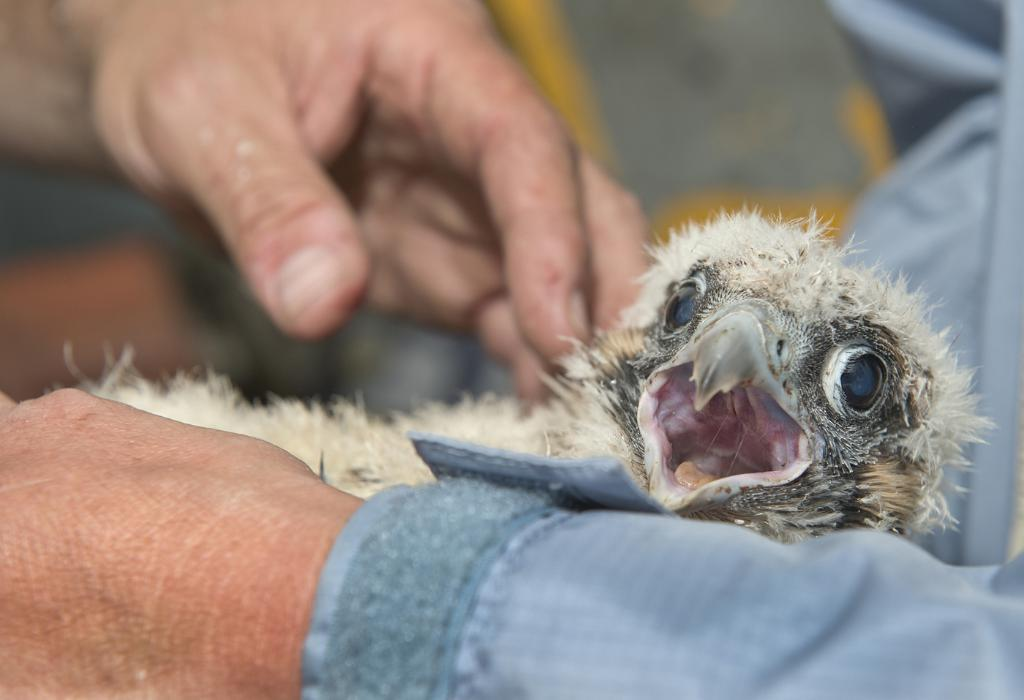What is happening in the foreground of the picture? There is a person in the foreground of the picture, and they are holding a bird. Can you describe the bird's appearance or behavior? The bird has its mouth open. What word does the bird say in the image? Birds do not have the ability to speak or say words, so there is no word spoken by the bird in the image. 